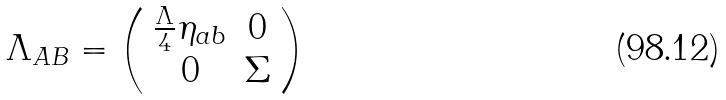Convert formula to latex. <formula><loc_0><loc_0><loc_500><loc_500>\Lambda _ { A B } = \left ( \begin{array} { c c } \frac { \Lambda } { 4 } \eta _ { a b } & 0 \\ 0 & \Sigma \end{array} \right )</formula> 